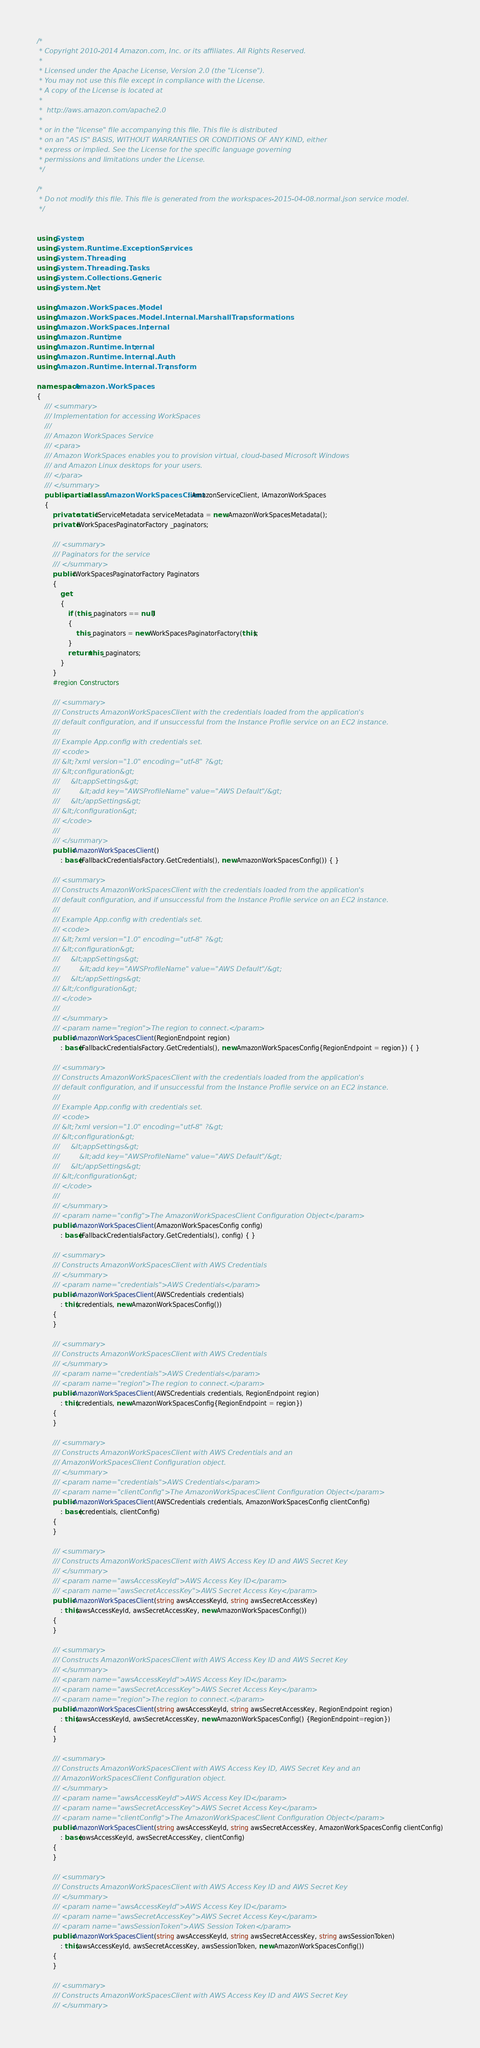Convert code to text. <code><loc_0><loc_0><loc_500><loc_500><_C#_>/*
 * Copyright 2010-2014 Amazon.com, Inc. or its affiliates. All Rights Reserved.
 * 
 * Licensed under the Apache License, Version 2.0 (the "License").
 * You may not use this file except in compliance with the License.
 * A copy of the License is located at
 * 
 *  http://aws.amazon.com/apache2.0
 * 
 * or in the "license" file accompanying this file. This file is distributed
 * on an "AS IS" BASIS, WITHOUT WARRANTIES OR CONDITIONS OF ANY KIND, either
 * express or implied. See the License for the specific language governing
 * permissions and limitations under the License.
 */

/*
 * Do not modify this file. This file is generated from the workspaces-2015-04-08.normal.json service model.
 */


using System;
using System.Runtime.ExceptionServices;
using System.Threading;
using System.Threading.Tasks;
using System.Collections.Generic;
using System.Net;

using Amazon.WorkSpaces.Model;
using Amazon.WorkSpaces.Model.Internal.MarshallTransformations;
using Amazon.WorkSpaces.Internal;
using Amazon.Runtime;
using Amazon.Runtime.Internal;
using Amazon.Runtime.Internal.Auth;
using Amazon.Runtime.Internal.Transform;

namespace Amazon.WorkSpaces
{
    /// <summary>
    /// Implementation for accessing WorkSpaces
    ///
    /// Amazon WorkSpaces Service 
    /// <para>
    /// Amazon WorkSpaces enables you to provision virtual, cloud-based Microsoft Windows
    /// and Amazon Linux desktops for your users.
    /// </para>
    /// </summary>
    public partial class AmazonWorkSpacesClient : AmazonServiceClient, IAmazonWorkSpaces
    {
        private static IServiceMetadata serviceMetadata = new AmazonWorkSpacesMetadata();
        private IWorkSpacesPaginatorFactory _paginators;

        /// <summary>
        /// Paginators for the service
        /// </summary>
        public IWorkSpacesPaginatorFactory Paginators 
        {
            get 
            {
                if (this._paginators == null) 
                {
                    this._paginators = new WorkSpacesPaginatorFactory(this);
                }
                return this._paginators;
            }
        }
        #region Constructors

        /// <summary>
        /// Constructs AmazonWorkSpacesClient with the credentials loaded from the application's
        /// default configuration, and if unsuccessful from the Instance Profile service on an EC2 instance.
        /// 
        /// Example App.config with credentials set. 
        /// <code>
        /// &lt;?xml version="1.0" encoding="utf-8" ?&gt;
        /// &lt;configuration&gt;
        ///     &lt;appSettings&gt;
        ///         &lt;add key="AWSProfileName" value="AWS Default"/&gt;
        ///     &lt;/appSettings&gt;
        /// &lt;/configuration&gt;
        /// </code>
        ///
        /// </summary>
        public AmazonWorkSpacesClient()
            : base(FallbackCredentialsFactory.GetCredentials(), new AmazonWorkSpacesConfig()) { }

        /// <summary>
        /// Constructs AmazonWorkSpacesClient with the credentials loaded from the application's
        /// default configuration, and if unsuccessful from the Instance Profile service on an EC2 instance.
        /// 
        /// Example App.config with credentials set. 
        /// <code>
        /// &lt;?xml version="1.0" encoding="utf-8" ?&gt;
        /// &lt;configuration&gt;
        ///     &lt;appSettings&gt;
        ///         &lt;add key="AWSProfileName" value="AWS Default"/&gt;
        ///     &lt;/appSettings&gt;
        /// &lt;/configuration&gt;
        /// </code>
        ///
        /// </summary>
        /// <param name="region">The region to connect.</param>
        public AmazonWorkSpacesClient(RegionEndpoint region)
            : base(FallbackCredentialsFactory.GetCredentials(), new AmazonWorkSpacesConfig{RegionEndpoint = region}) { }

        /// <summary>
        /// Constructs AmazonWorkSpacesClient with the credentials loaded from the application's
        /// default configuration, and if unsuccessful from the Instance Profile service on an EC2 instance.
        /// 
        /// Example App.config with credentials set. 
        /// <code>
        /// &lt;?xml version="1.0" encoding="utf-8" ?&gt;
        /// &lt;configuration&gt;
        ///     &lt;appSettings&gt;
        ///         &lt;add key="AWSProfileName" value="AWS Default"/&gt;
        ///     &lt;/appSettings&gt;
        /// &lt;/configuration&gt;
        /// </code>
        ///
        /// </summary>
        /// <param name="config">The AmazonWorkSpacesClient Configuration Object</param>
        public AmazonWorkSpacesClient(AmazonWorkSpacesConfig config)
            : base(FallbackCredentialsFactory.GetCredentials(), config) { }

        /// <summary>
        /// Constructs AmazonWorkSpacesClient with AWS Credentials
        /// </summary>
        /// <param name="credentials">AWS Credentials</param>
        public AmazonWorkSpacesClient(AWSCredentials credentials)
            : this(credentials, new AmazonWorkSpacesConfig())
        {
        }

        /// <summary>
        /// Constructs AmazonWorkSpacesClient with AWS Credentials
        /// </summary>
        /// <param name="credentials">AWS Credentials</param>
        /// <param name="region">The region to connect.</param>
        public AmazonWorkSpacesClient(AWSCredentials credentials, RegionEndpoint region)
            : this(credentials, new AmazonWorkSpacesConfig{RegionEndpoint = region})
        {
        }

        /// <summary>
        /// Constructs AmazonWorkSpacesClient with AWS Credentials and an
        /// AmazonWorkSpacesClient Configuration object.
        /// </summary>
        /// <param name="credentials">AWS Credentials</param>
        /// <param name="clientConfig">The AmazonWorkSpacesClient Configuration Object</param>
        public AmazonWorkSpacesClient(AWSCredentials credentials, AmazonWorkSpacesConfig clientConfig)
            : base(credentials, clientConfig)
        {
        }

        /// <summary>
        /// Constructs AmazonWorkSpacesClient with AWS Access Key ID and AWS Secret Key
        /// </summary>
        /// <param name="awsAccessKeyId">AWS Access Key ID</param>
        /// <param name="awsSecretAccessKey">AWS Secret Access Key</param>
        public AmazonWorkSpacesClient(string awsAccessKeyId, string awsSecretAccessKey)
            : this(awsAccessKeyId, awsSecretAccessKey, new AmazonWorkSpacesConfig())
        {
        }

        /// <summary>
        /// Constructs AmazonWorkSpacesClient with AWS Access Key ID and AWS Secret Key
        /// </summary>
        /// <param name="awsAccessKeyId">AWS Access Key ID</param>
        /// <param name="awsSecretAccessKey">AWS Secret Access Key</param>
        /// <param name="region">The region to connect.</param>
        public AmazonWorkSpacesClient(string awsAccessKeyId, string awsSecretAccessKey, RegionEndpoint region)
            : this(awsAccessKeyId, awsSecretAccessKey, new AmazonWorkSpacesConfig() {RegionEndpoint=region})
        {
        }

        /// <summary>
        /// Constructs AmazonWorkSpacesClient with AWS Access Key ID, AWS Secret Key and an
        /// AmazonWorkSpacesClient Configuration object. 
        /// </summary>
        /// <param name="awsAccessKeyId">AWS Access Key ID</param>
        /// <param name="awsSecretAccessKey">AWS Secret Access Key</param>
        /// <param name="clientConfig">The AmazonWorkSpacesClient Configuration Object</param>
        public AmazonWorkSpacesClient(string awsAccessKeyId, string awsSecretAccessKey, AmazonWorkSpacesConfig clientConfig)
            : base(awsAccessKeyId, awsSecretAccessKey, clientConfig)
        {
        }

        /// <summary>
        /// Constructs AmazonWorkSpacesClient with AWS Access Key ID and AWS Secret Key
        /// </summary>
        /// <param name="awsAccessKeyId">AWS Access Key ID</param>
        /// <param name="awsSecretAccessKey">AWS Secret Access Key</param>
        /// <param name="awsSessionToken">AWS Session Token</param>
        public AmazonWorkSpacesClient(string awsAccessKeyId, string awsSecretAccessKey, string awsSessionToken)
            : this(awsAccessKeyId, awsSecretAccessKey, awsSessionToken, new AmazonWorkSpacesConfig())
        {
        }

        /// <summary>
        /// Constructs AmazonWorkSpacesClient with AWS Access Key ID and AWS Secret Key
        /// </summary></code> 